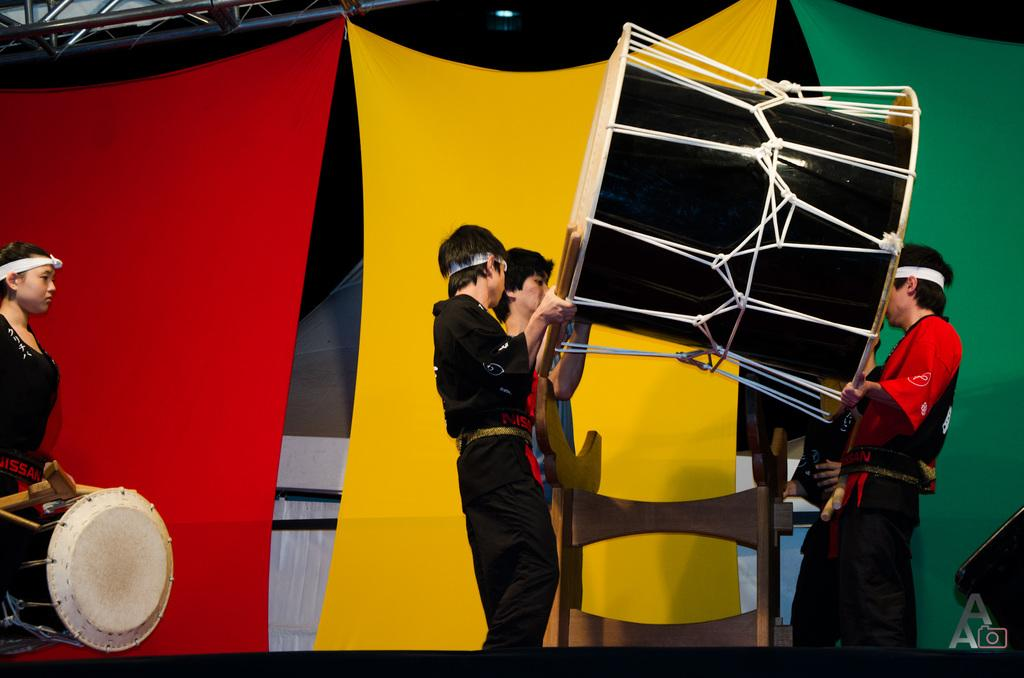What are the persons in the image doing? Some persons are holding drums, and one person is wearing a drum. What might the persons be participating in? They might be participating in a musical performance or event. What can be seen in the background of the image? There are curtains visible in the background. What object is present in the image that might be used for hanging or supporting something? There is a rod in the image. What type of organization is being discussed during the breakfast meeting in the image? There is no breakfast meeting or organization present in the image; it features persons playing drums. 